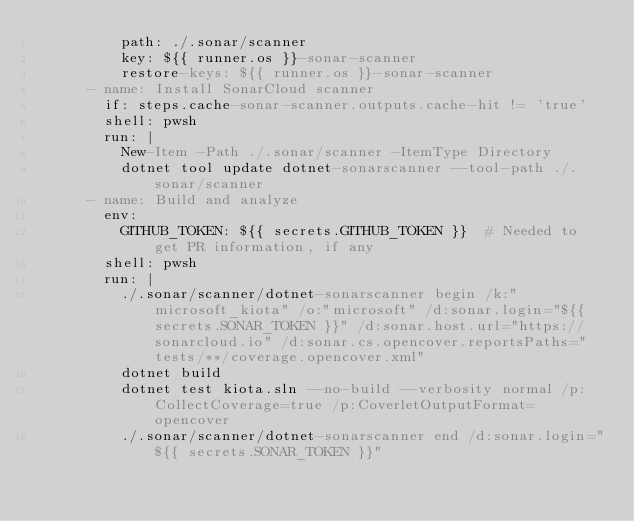<code> <loc_0><loc_0><loc_500><loc_500><_YAML_>          path: ./.sonar/scanner
          key: ${{ runner.os }}-sonar-scanner
          restore-keys: ${{ runner.os }}-sonar-scanner
      - name: Install SonarCloud scanner
        if: steps.cache-sonar-scanner.outputs.cache-hit != 'true'
        shell: pwsh
        run: |
          New-Item -Path ./.sonar/scanner -ItemType Directory
          dotnet tool update dotnet-sonarscanner --tool-path ./.sonar/scanner
      - name: Build and analyze
        env:
          GITHUB_TOKEN: ${{ secrets.GITHUB_TOKEN }}  # Needed to get PR information, if any
        shell: pwsh
        run: |
          ./.sonar/scanner/dotnet-sonarscanner begin /k:"microsoft_kiota" /o:"microsoft" /d:sonar.login="${{ secrets.SONAR_TOKEN }}" /d:sonar.host.url="https://sonarcloud.io" /d:sonar.cs.opencover.reportsPaths="tests/**/coverage.opencover.xml"
          dotnet build
          dotnet test kiota.sln --no-build --verbosity normal /p:CollectCoverage=true /p:CoverletOutputFormat=opencover
          ./.sonar/scanner/dotnet-sonarscanner end /d:sonar.login="${{ secrets.SONAR_TOKEN }}"</code> 